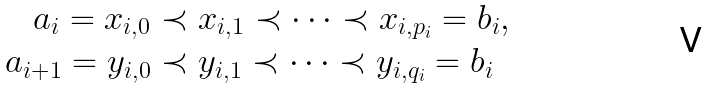<formula> <loc_0><loc_0><loc_500><loc_500>a _ { i } = x _ { i , 0 } & \prec x _ { i , 1 } \prec \cdots \prec x _ { i , p _ { i } } = b _ { i } , \\ a _ { i + 1 } = y _ { i , 0 } & \prec y _ { i , 1 } \prec \cdots \prec y _ { i , q _ { i } } = b _ { i }</formula> 